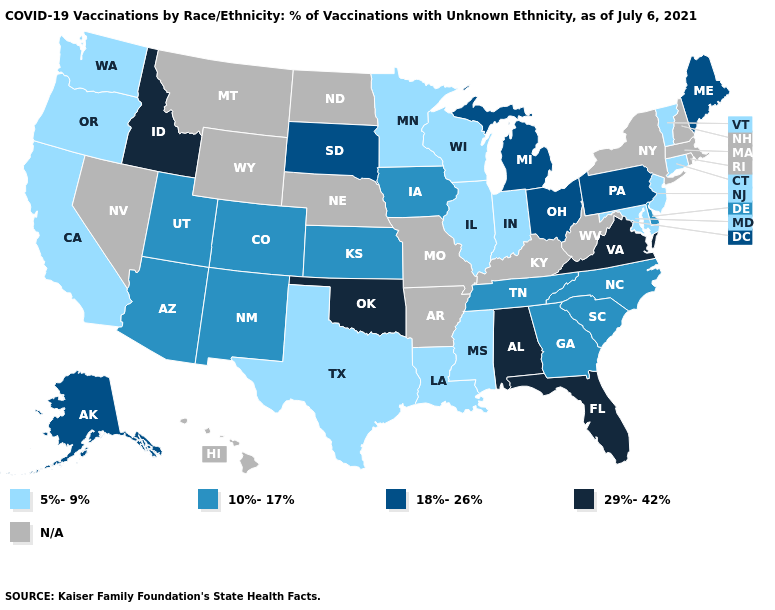What is the highest value in states that border Louisiana?
Short answer required. 5%-9%. Name the states that have a value in the range 10%-17%?
Keep it brief. Arizona, Colorado, Delaware, Georgia, Iowa, Kansas, New Mexico, North Carolina, South Carolina, Tennessee, Utah. Does the map have missing data?
Be succinct. Yes. Among the states that border Indiana , which have the highest value?
Keep it brief. Michigan, Ohio. Name the states that have a value in the range N/A?
Answer briefly. Arkansas, Hawaii, Kentucky, Massachusetts, Missouri, Montana, Nebraska, Nevada, New Hampshire, New York, North Dakota, Rhode Island, West Virginia, Wyoming. What is the lowest value in the South?
Write a very short answer. 5%-9%. What is the value of Delaware?
Answer briefly. 10%-17%. Does the first symbol in the legend represent the smallest category?
Answer briefly. Yes. What is the value of Iowa?
Give a very brief answer. 10%-17%. What is the value of Hawaii?
Answer briefly. N/A. Name the states that have a value in the range 10%-17%?
Quick response, please. Arizona, Colorado, Delaware, Georgia, Iowa, Kansas, New Mexico, North Carolina, South Carolina, Tennessee, Utah. What is the value of Wyoming?
Give a very brief answer. N/A. Name the states that have a value in the range 10%-17%?
Write a very short answer. Arizona, Colorado, Delaware, Georgia, Iowa, Kansas, New Mexico, North Carolina, South Carolina, Tennessee, Utah. 